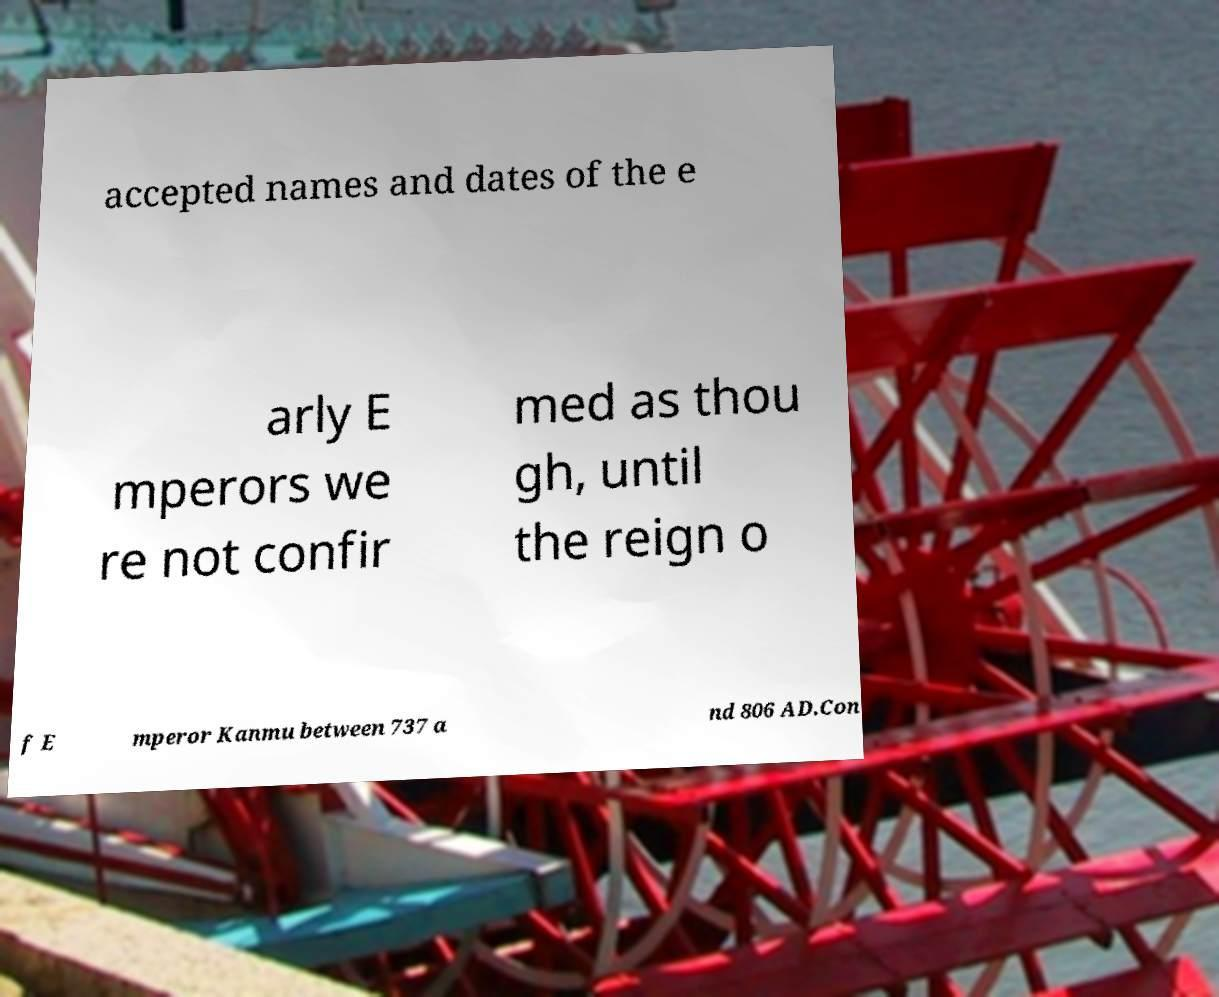For documentation purposes, I need the text within this image transcribed. Could you provide that? accepted names and dates of the e arly E mperors we re not confir med as thou gh, until the reign o f E mperor Kanmu between 737 a nd 806 AD.Con 